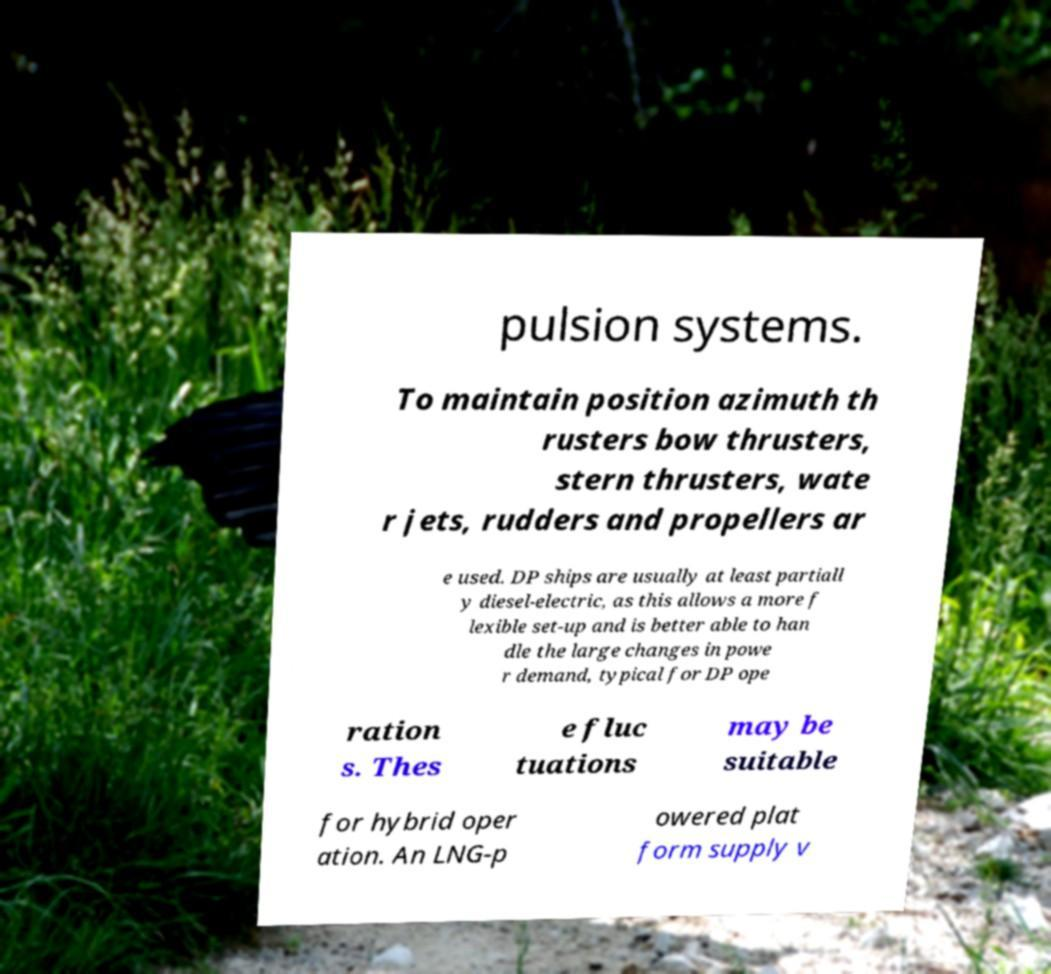Can you accurately transcribe the text from the provided image for me? pulsion systems. To maintain position azimuth th rusters bow thrusters, stern thrusters, wate r jets, rudders and propellers ar e used. DP ships are usually at least partiall y diesel-electric, as this allows a more f lexible set-up and is better able to han dle the large changes in powe r demand, typical for DP ope ration s. Thes e fluc tuations may be suitable for hybrid oper ation. An LNG-p owered plat form supply v 